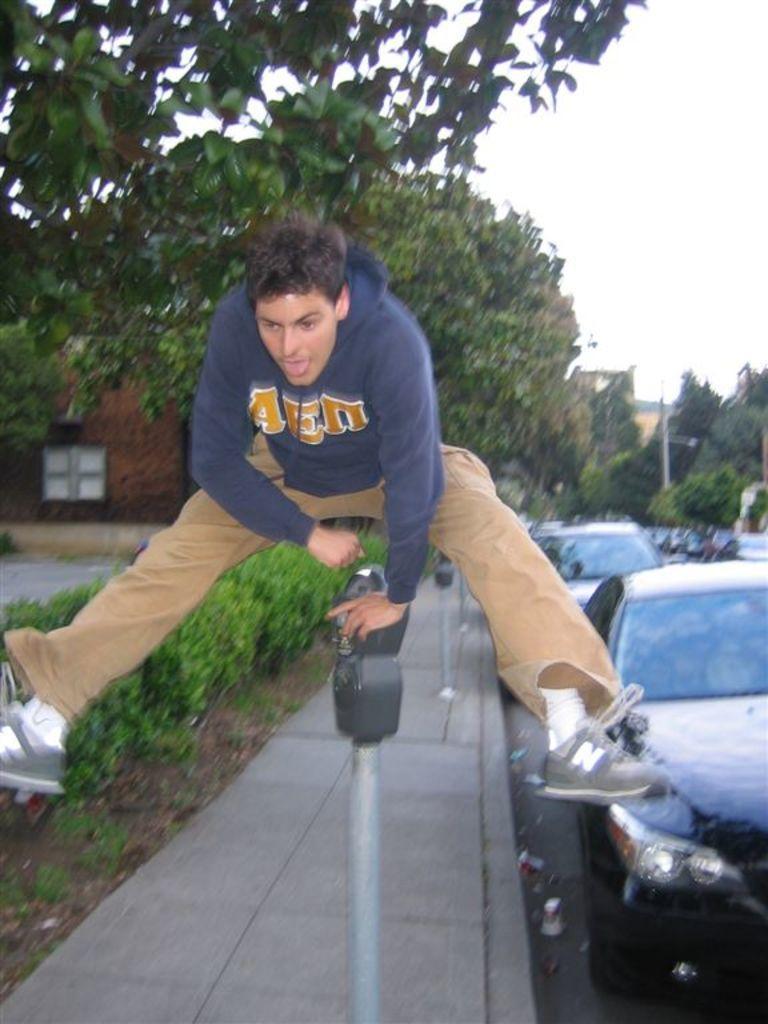How would you summarize this image in a sentence or two? In this picture I can see there is a person jumping and there are cars, trees and buildings. 